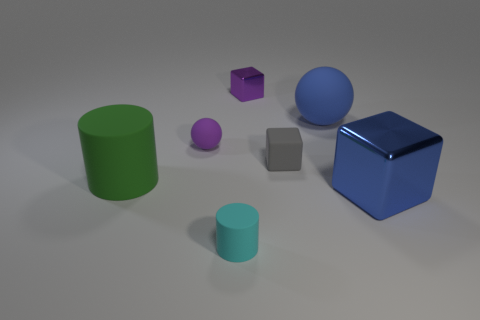Subtract all balls. How many objects are left? 5 Subtract 1 balls. How many balls are left? 1 Subtract all gray cylinders. Subtract all blue blocks. How many cylinders are left? 2 Subtract all yellow spheres. How many gray cubes are left? 1 Subtract all small purple cubes. Subtract all small green metallic cylinders. How many objects are left? 6 Add 6 gray matte things. How many gray matte things are left? 7 Add 3 large green cubes. How many large green cubes exist? 3 Add 1 spheres. How many objects exist? 8 Subtract all purple balls. How many balls are left? 1 Subtract all tiny gray blocks. How many blocks are left? 2 